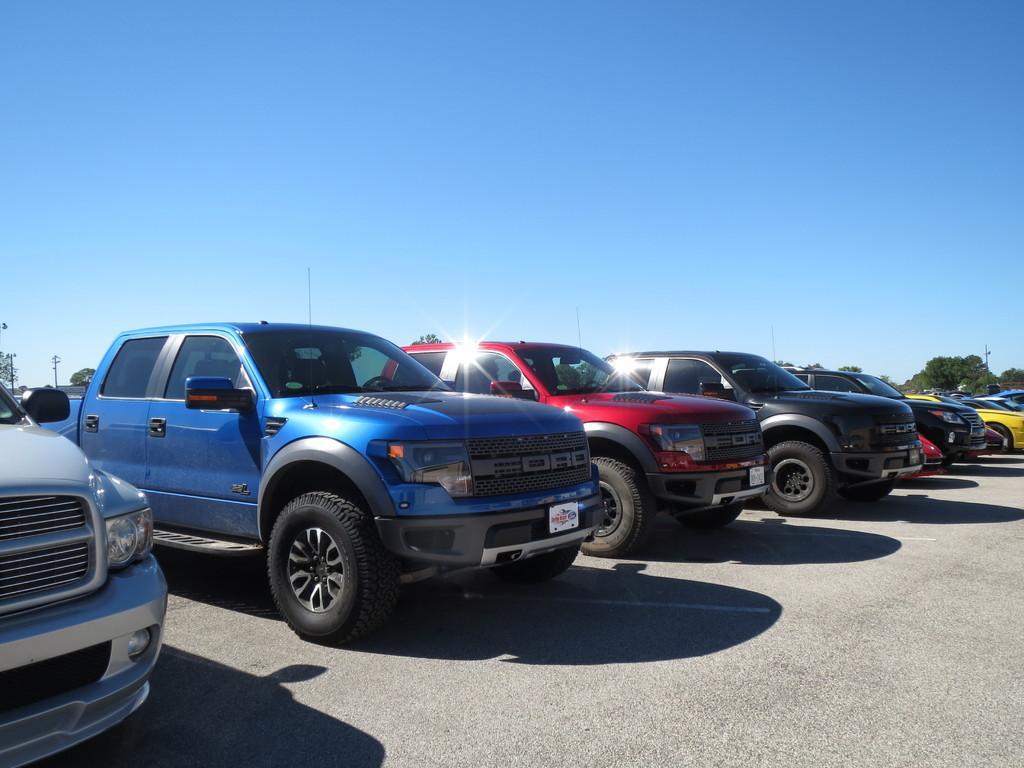Can you describe this image briefly? This image is clicked on the road. There are many cars parked on the road. In the background there are trees and poles. At the top there is the sky. 